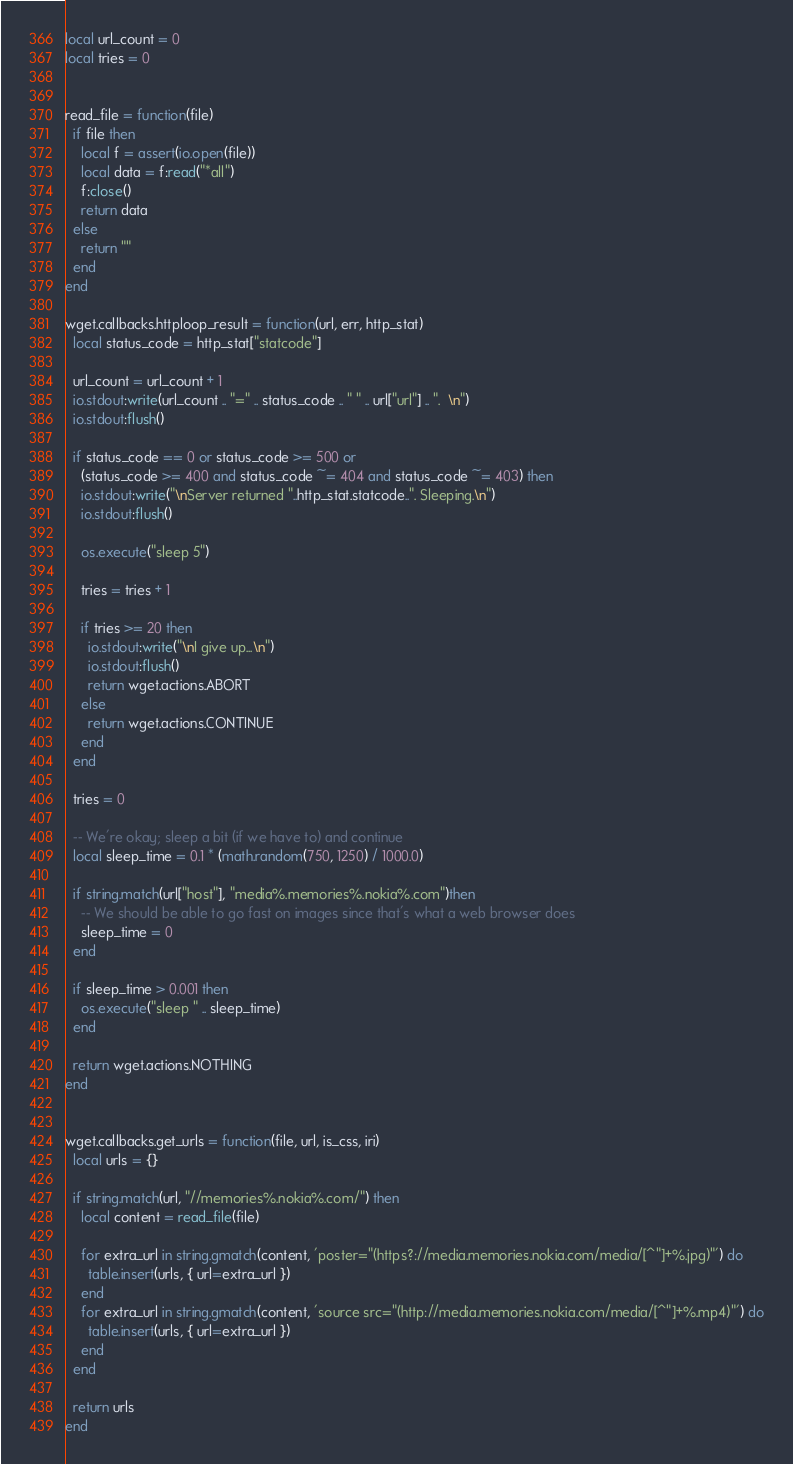<code> <loc_0><loc_0><loc_500><loc_500><_Lua_>local url_count = 0
local tries = 0


read_file = function(file)
  if file then
    local f = assert(io.open(file))
    local data = f:read("*all")
    f:close()
    return data
  else
    return ""
  end
end

wget.callbacks.httploop_result = function(url, err, http_stat)
  local status_code = http_stat["statcode"]

  url_count = url_count + 1
  io.stdout:write(url_count .. "=" .. status_code .. " " .. url["url"] .. ".  \n")
  io.stdout:flush()

  if status_code == 0 or status_code >= 500 or
    (status_code >= 400 and status_code ~= 404 and status_code ~= 403) then
    io.stdout:write("\nServer returned "..http_stat.statcode..". Sleeping.\n")
    io.stdout:flush()

    os.execute("sleep 5")

    tries = tries + 1

    if tries >= 20 then
      io.stdout:write("\nI give up...\n")
      io.stdout:flush()
      return wget.actions.ABORT
    else
      return wget.actions.CONTINUE
    end
  end

  tries = 0

  -- We're okay; sleep a bit (if we have to) and continue
  local sleep_time = 0.1 * (math.random(750, 1250) / 1000.0)

  if string.match(url["host"], "media%.memories%.nokia%.com")then
    -- We should be able to go fast on images since that's what a web browser does
    sleep_time = 0
  end

  if sleep_time > 0.001 then
    os.execute("sleep " .. sleep_time)
  end

  return wget.actions.NOTHING
end


wget.callbacks.get_urls = function(file, url, is_css, iri)
  local urls = {}

  if string.match(url, "//memories%.nokia%.com/") then
    local content = read_file(file)

    for extra_url in string.gmatch(content, 'poster="(https?://media.memories.nokia.com/media/[^"]+%.jpg)"') do
      table.insert(urls, { url=extra_url })
    end
    for extra_url in string.gmatch(content, 'source src="(http://media.memories.nokia.com/media/[^"]+%.mp4)"') do
      table.insert(urls, { url=extra_url })
    end
  end

  return urls
end
</code> 